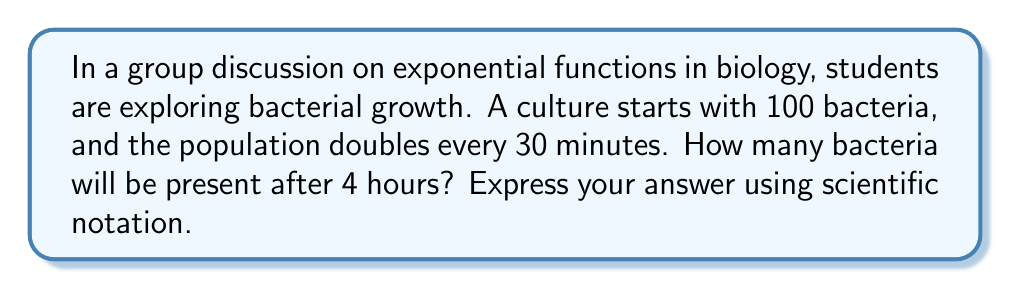Give your solution to this math problem. Let's approach this step-by-step:

1) First, we need to determine how many doubling periods occur in 4 hours:
   4 hours = 240 minutes
   Number of doubling periods = 240 minutes ÷ 30 minutes = 8

2) We can express this growth using an exponential function:
   $N = N_0 \cdot 2^t$
   Where $N$ is the final number of bacteria, $N_0$ is the initial number, and $t$ is the number of doubling periods.

3) Plugging in our values:
   $N = 100 \cdot 2^8$

4) Now, let's calculate $2^8$:
   $2^8 = 2 \cdot 2 \cdot 2 \cdot 2 \cdot 2 \cdot 2 \cdot 2 \cdot 2 = 256$

5) Therefore:
   $N = 100 \cdot 256 = 25,600$

6) To express this in scientific notation:
   $25,600 = 2.56 \times 10^4$
Answer: $2.56 \times 10^4$ 